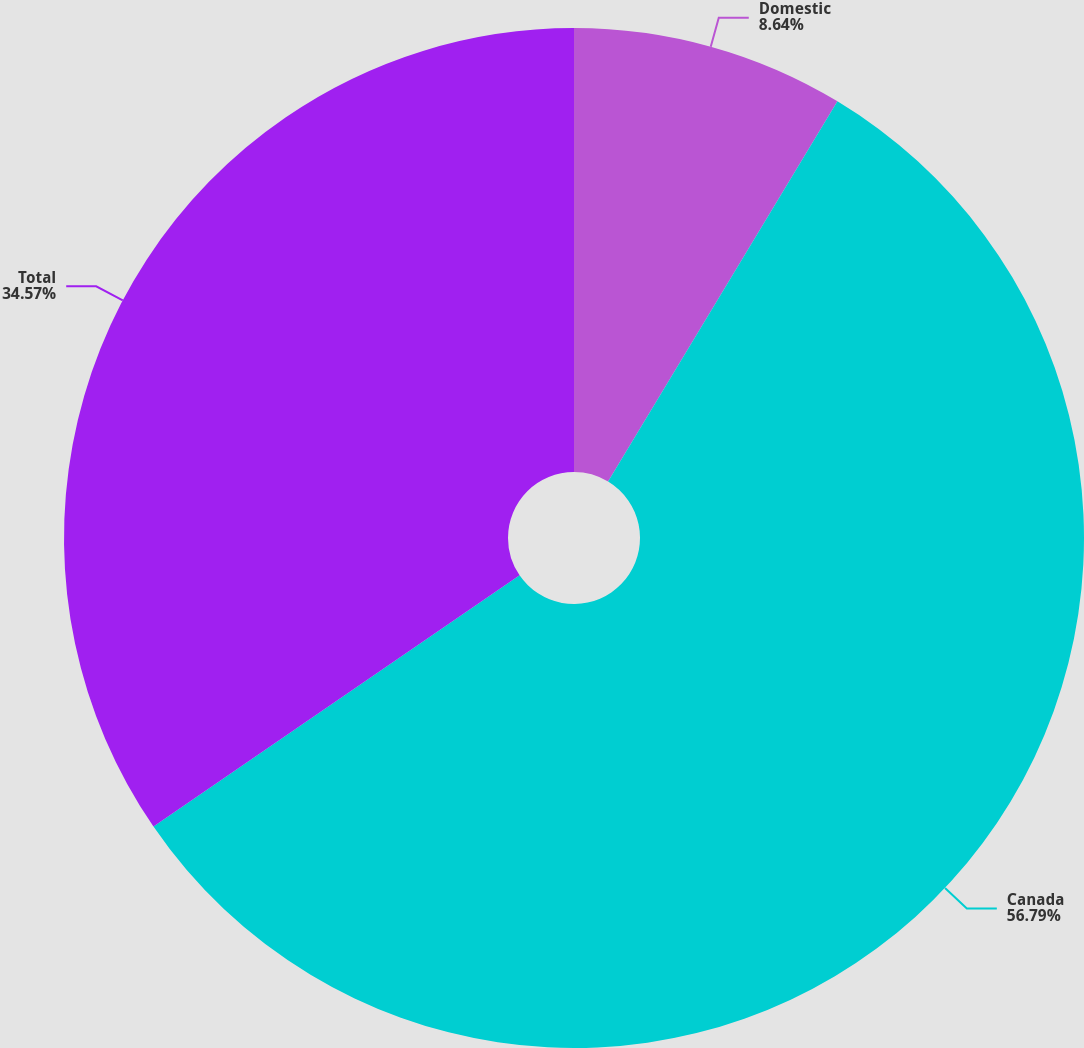<chart> <loc_0><loc_0><loc_500><loc_500><pie_chart><fcel>Domestic<fcel>Canada<fcel>Total<nl><fcel>8.64%<fcel>56.79%<fcel>34.57%<nl></chart> 